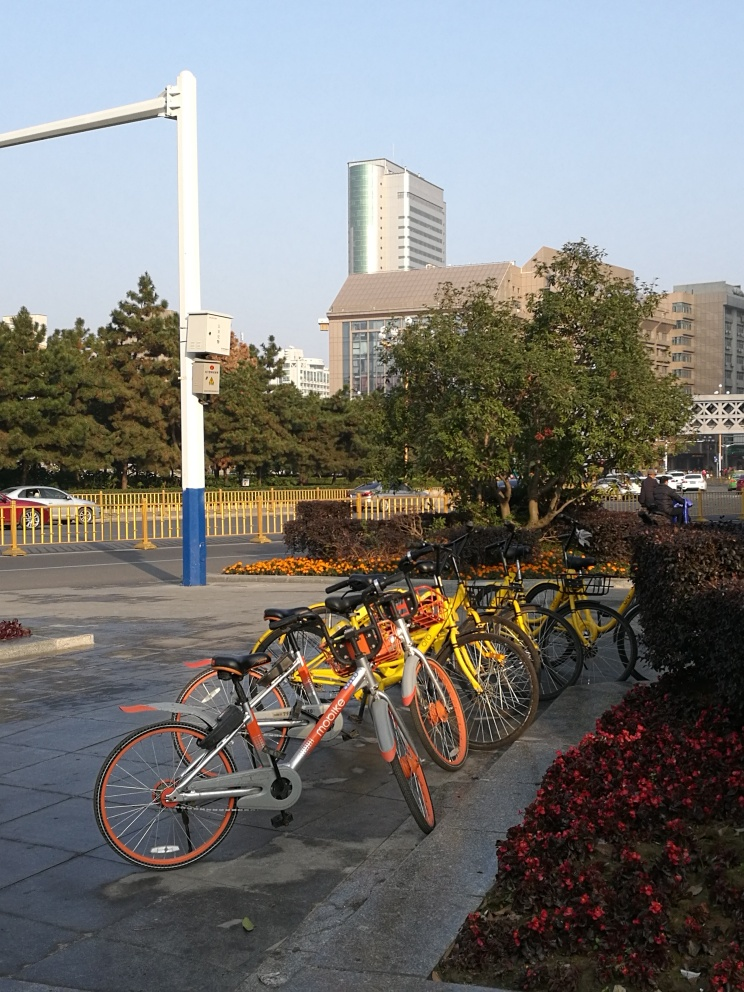What do the bicycles in this image suggest about the local culture? The presence of multiple bicycles from a bike-sharing service points to a culture that values sustainable transportation options. It implies an environmentally conscious or health-aware population that supports alternative modes of transport besides cars. Additionally, it hints at a well-connected urban environment where such services are economically feasible and utilized. 